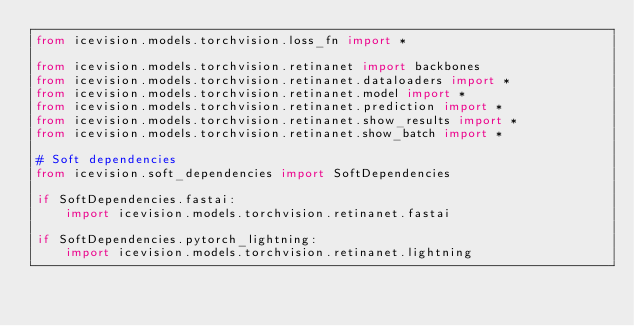<code> <loc_0><loc_0><loc_500><loc_500><_Python_>from icevision.models.torchvision.loss_fn import *

from icevision.models.torchvision.retinanet import backbones
from icevision.models.torchvision.retinanet.dataloaders import *
from icevision.models.torchvision.retinanet.model import *
from icevision.models.torchvision.retinanet.prediction import *
from icevision.models.torchvision.retinanet.show_results import *
from icevision.models.torchvision.retinanet.show_batch import *

# Soft dependencies
from icevision.soft_dependencies import SoftDependencies

if SoftDependencies.fastai:
    import icevision.models.torchvision.retinanet.fastai

if SoftDependencies.pytorch_lightning:
    import icevision.models.torchvision.retinanet.lightning
</code> 